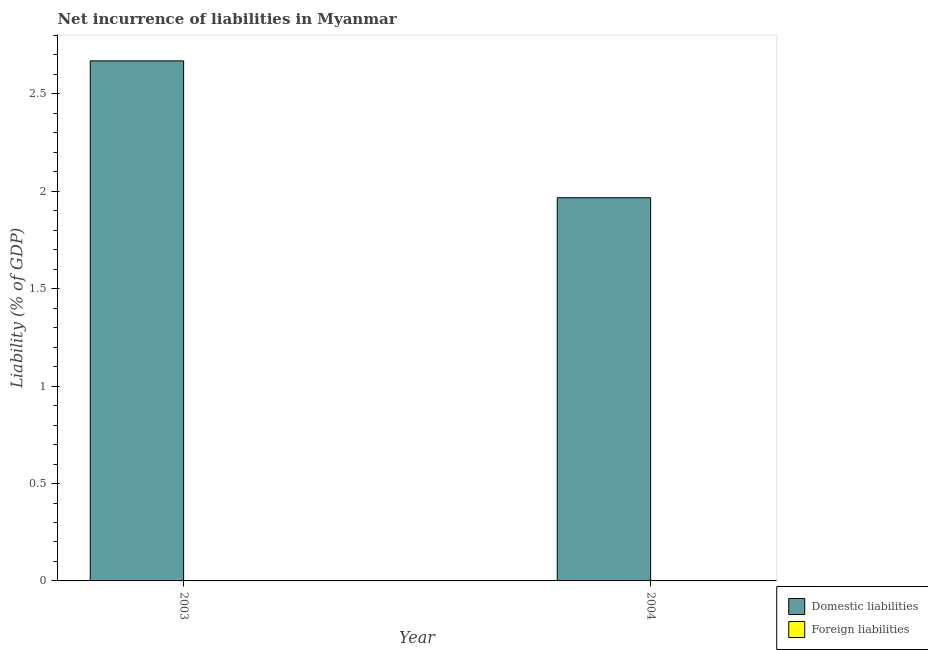How many different coloured bars are there?
Offer a terse response. 1. What is the label of the 2nd group of bars from the left?
Your response must be concise. 2004. What is the incurrence of domestic liabilities in 2004?
Make the answer very short. 1.97. Across all years, what is the maximum incurrence of domestic liabilities?
Your answer should be very brief. 2.67. What is the total incurrence of foreign liabilities in the graph?
Your answer should be compact. 0. What is the difference between the incurrence of domestic liabilities in 2003 and that in 2004?
Your answer should be compact. 0.7. In the year 2003, what is the difference between the incurrence of domestic liabilities and incurrence of foreign liabilities?
Offer a very short reply. 0. What is the ratio of the incurrence of domestic liabilities in 2003 to that in 2004?
Offer a very short reply. 1.36. Is the incurrence of domestic liabilities in 2003 less than that in 2004?
Your answer should be very brief. No. How many bars are there?
Provide a short and direct response. 2. How many years are there in the graph?
Make the answer very short. 2. What is the difference between two consecutive major ticks on the Y-axis?
Keep it short and to the point. 0.5. Are the values on the major ticks of Y-axis written in scientific E-notation?
Ensure brevity in your answer.  No. Does the graph contain any zero values?
Your answer should be compact. Yes. Where does the legend appear in the graph?
Your response must be concise. Bottom right. What is the title of the graph?
Offer a terse response. Net incurrence of liabilities in Myanmar. What is the label or title of the Y-axis?
Make the answer very short. Liability (% of GDP). What is the Liability (% of GDP) of Domestic liabilities in 2003?
Offer a terse response. 2.67. What is the Liability (% of GDP) in Domestic liabilities in 2004?
Ensure brevity in your answer.  1.97. What is the Liability (% of GDP) in Foreign liabilities in 2004?
Provide a short and direct response. 0. Across all years, what is the maximum Liability (% of GDP) of Domestic liabilities?
Your response must be concise. 2.67. Across all years, what is the minimum Liability (% of GDP) in Domestic liabilities?
Offer a terse response. 1.97. What is the total Liability (% of GDP) of Domestic liabilities in the graph?
Offer a very short reply. 4.64. What is the difference between the Liability (% of GDP) in Domestic liabilities in 2003 and that in 2004?
Keep it short and to the point. 0.7. What is the average Liability (% of GDP) of Domestic liabilities per year?
Give a very brief answer. 2.32. What is the ratio of the Liability (% of GDP) of Domestic liabilities in 2003 to that in 2004?
Your response must be concise. 1.36. What is the difference between the highest and the second highest Liability (% of GDP) of Domestic liabilities?
Provide a short and direct response. 0.7. What is the difference between the highest and the lowest Liability (% of GDP) of Domestic liabilities?
Provide a succinct answer. 0.7. 